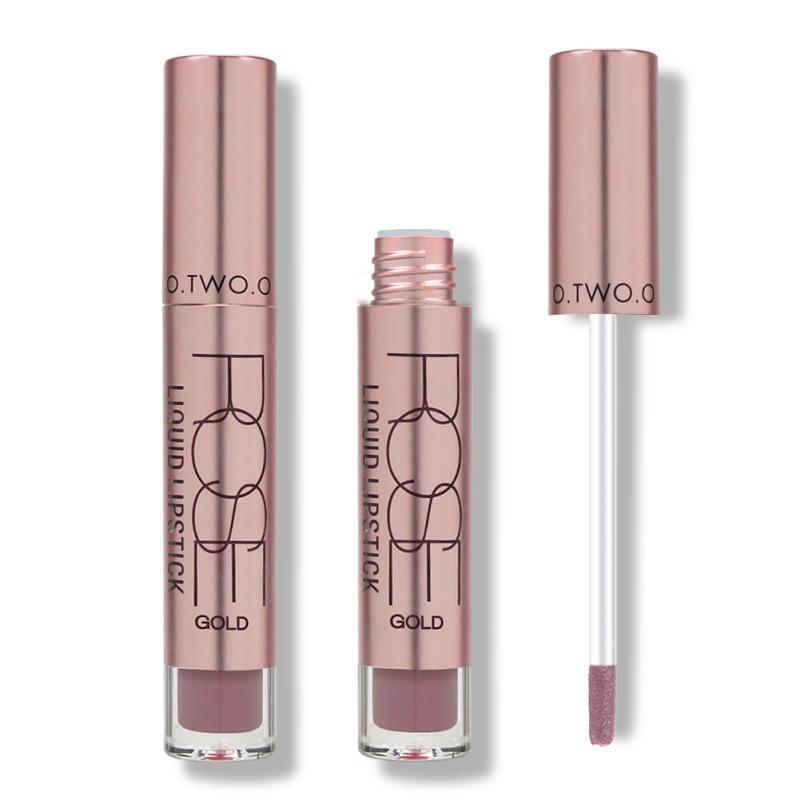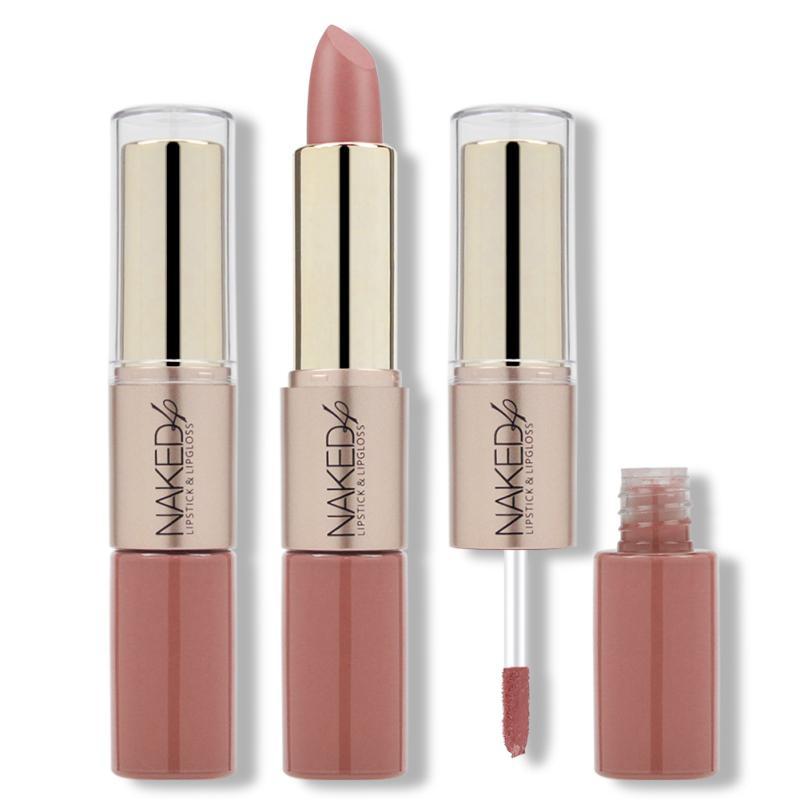The first image is the image on the left, the second image is the image on the right. Given the left and right images, does the statement "An image shows only an unpackaged lipstick wand makeup, and does not show a standard tube lipstick or a box." hold true? Answer yes or no. Yes. 